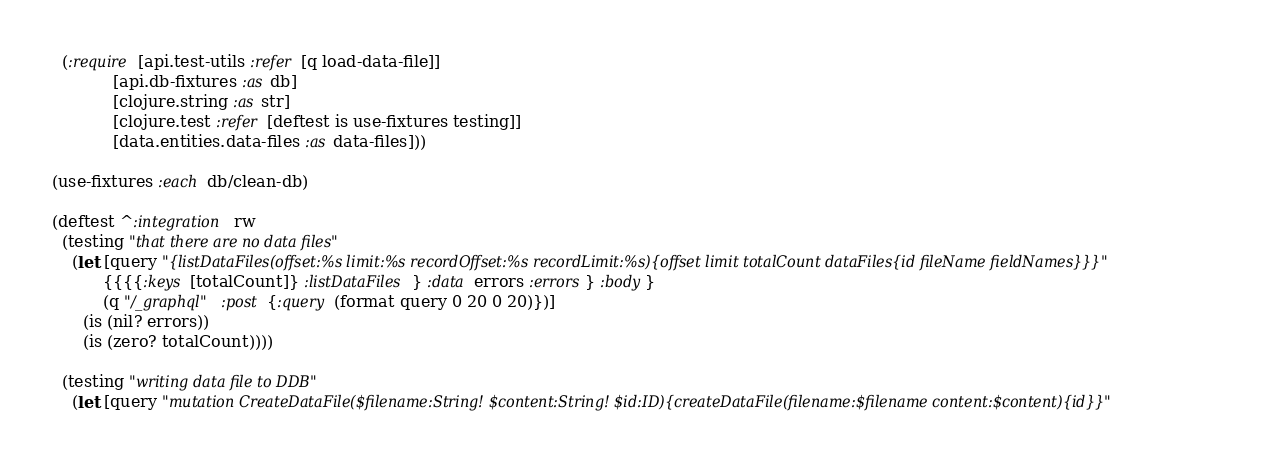Convert code to text. <code><loc_0><loc_0><loc_500><loc_500><_Clojure_>  (:require [api.test-utils :refer [q load-data-file]]
            [api.db-fixtures :as db]
            [clojure.string :as str]
            [clojure.test :refer [deftest is use-fixtures testing]]
            [data.entities.data-files :as data-files]))

(use-fixtures :each db/clean-db)

(deftest ^:integration rw
  (testing "that there are no data files"
    (let [query "{listDataFiles(offset:%s limit:%s recordOffset:%s recordLimit:%s){offset limit totalCount dataFiles{id fileName fieldNames}}}"
          {{{{:keys [totalCount]} :listDataFiles} :data errors :errors} :body}
          (q "/_graphql" :post {:query (format query 0 20 0 20)})]
      (is (nil? errors))
      (is (zero? totalCount))))

  (testing "writing data file to DDB"
    (let [query "mutation CreateDataFile($filename:String! $content:String! $id:ID){createDataFile(filename:$filename content:$content){id}}"</code> 